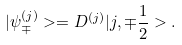<formula> <loc_0><loc_0><loc_500><loc_500>| { \psi } _ { \mp } ^ { ( j ) } > = D ^ { ( j ) } | j , { \mp } \frac { 1 } { 2 } > .</formula> 